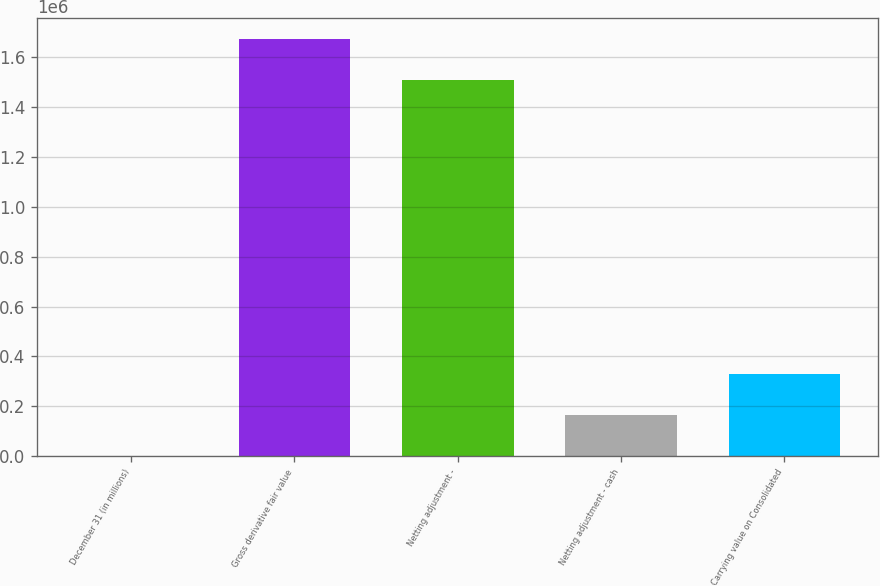Convert chart to OTSL. <chart><loc_0><loc_0><loc_500><loc_500><bar_chart><fcel>December 31 (in millions)<fcel>Gross derivative fair value<fcel>Netting adjustment -<fcel>Netting adjustment - cash<fcel>Carrying value on Consolidated<nl><fcel>2012<fcel>1.672e+06<fcel>1.50824e+06<fcel>165767<fcel>329521<nl></chart> 